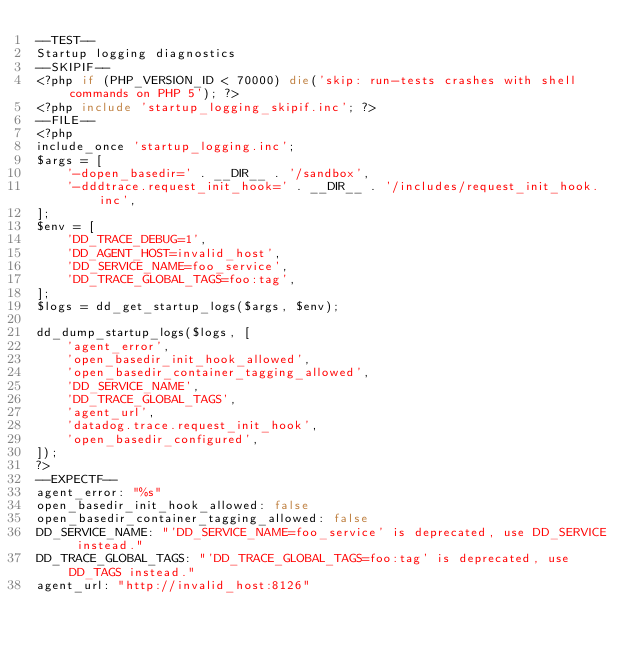<code> <loc_0><loc_0><loc_500><loc_500><_PHP_>--TEST--
Startup logging diagnostics
--SKIPIF--
<?php if (PHP_VERSION_ID < 70000) die('skip: run-tests crashes with shell commands on PHP 5'); ?>
<?php include 'startup_logging_skipif.inc'; ?>
--FILE--
<?php
include_once 'startup_logging.inc';
$args = [
    '-dopen_basedir=' . __DIR__ . '/sandbox',
    '-dddtrace.request_init_hook=' . __DIR__ . '/includes/request_init_hook.inc',
];
$env = [
    'DD_TRACE_DEBUG=1',
    'DD_AGENT_HOST=invalid_host',
    'DD_SERVICE_NAME=foo_service',
    'DD_TRACE_GLOBAL_TAGS=foo:tag',
];
$logs = dd_get_startup_logs($args, $env);

dd_dump_startup_logs($logs, [
    'agent_error',
    'open_basedir_init_hook_allowed',
    'open_basedir_container_tagging_allowed',
    'DD_SERVICE_NAME',
    'DD_TRACE_GLOBAL_TAGS',
    'agent_url',
    'datadog.trace.request_init_hook',
    'open_basedir_configured',
]);
?>
--EXPECTF--
agent_error: "%s"
open_basedir_init_hook_allowed: false
open_basedir_container_tagging_allowed: false
DD_SERVICE_NAME: "'DD_SERVICE_NAME=foo_service' is deprecated, use DD_SERVICE instead."
DD_TRACE_GLOBAL_TAGS: "'DD_TRACE_GLOBAL_TAGS=foo:tag' is deprecated, use DD_TAGS instead."
agent_url: "http://invalid_host:8126"</code> 